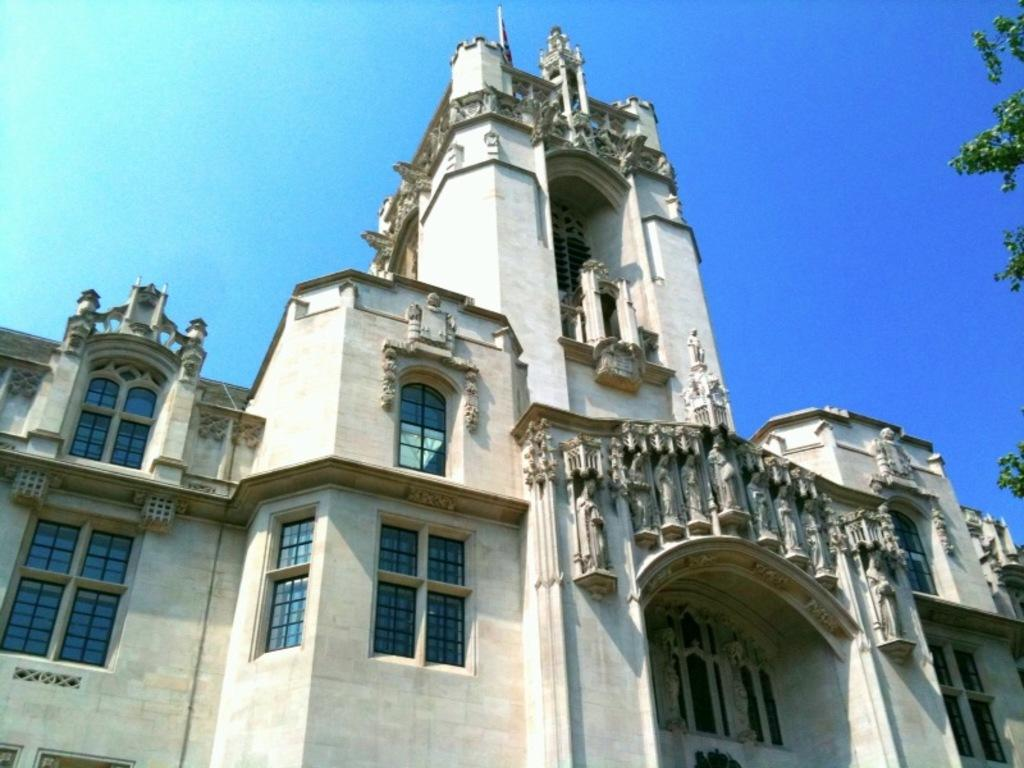What type of view is shown in the image? The image is an outside view. What structure can be seen in the image? There is a building in the image. What feature of the building is visible? The building has windows. What type of vegetation is on the right side of the image? There are leaves visible on the right side of the image. What is visible at the top of the image? The sky is visible at the top of the image. What nation is represented by the flag flying on the left side of the image? There is no flag visible in the image, so it is not possible to determine which nation is represented. What level of the building is shown in the image? The image does not show a specific level of the building; it is an outside view of the entire structure. 